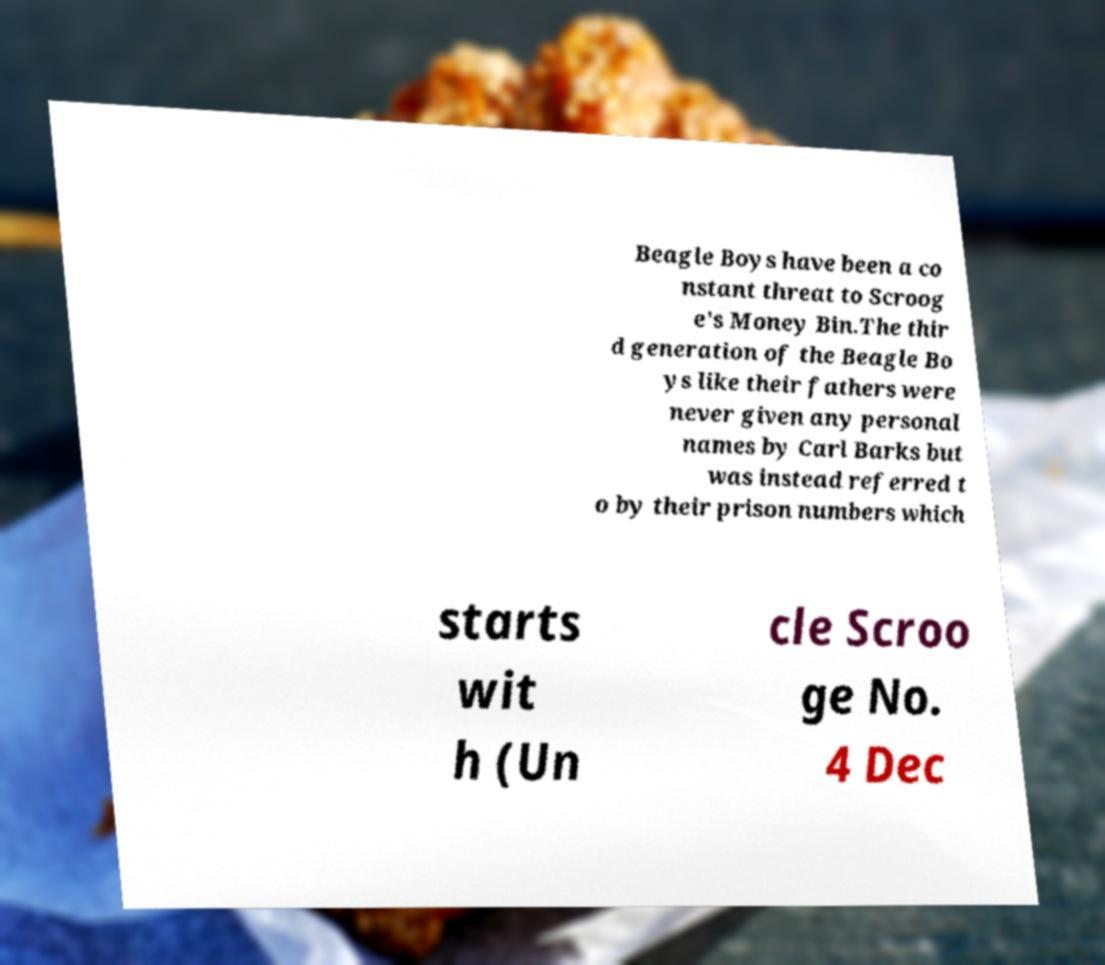Can you read and provide the text displayed in the image?This photo seems to have some interesting text. Can you extract and type it out for me? Beagle Boys have been a co nstant threat to Scroog e's Money Bin.The thir d generation of the Beagle Bo ys like their fathers were never given any personal names by Carl Barks but was instead referred t o by their prison numbers which starts wit h (Un cle Scroo ge No. 4 Dec 